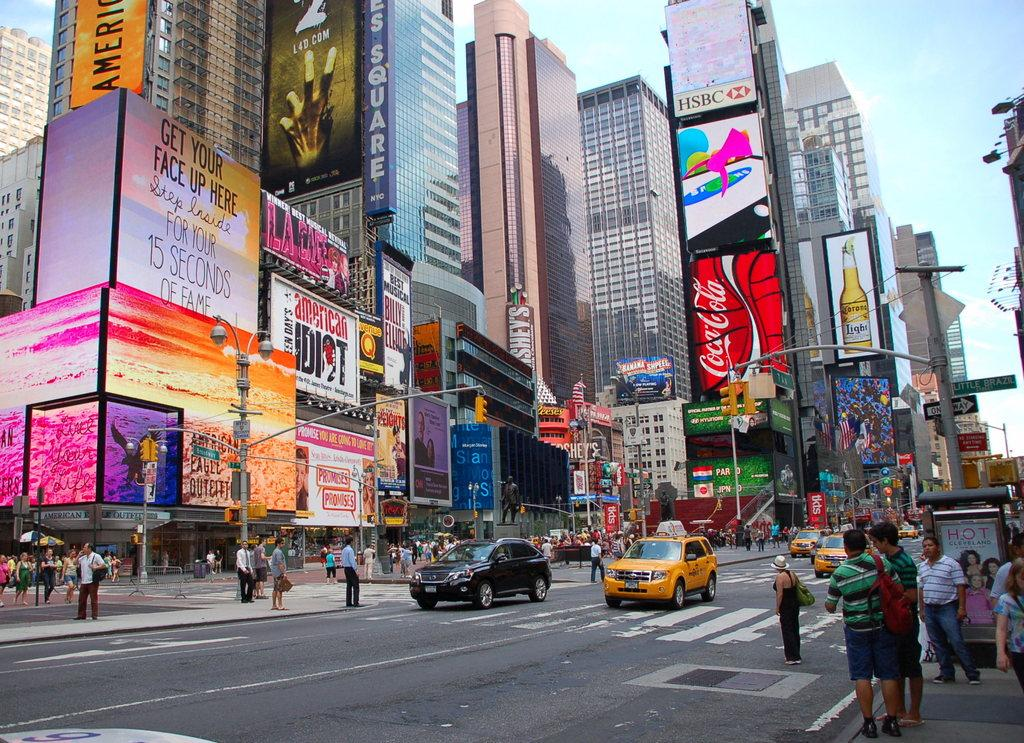<image>
Summarize the visual content of the image. A city street with many ads for things like CocaCola and Left 4 dead 2. 